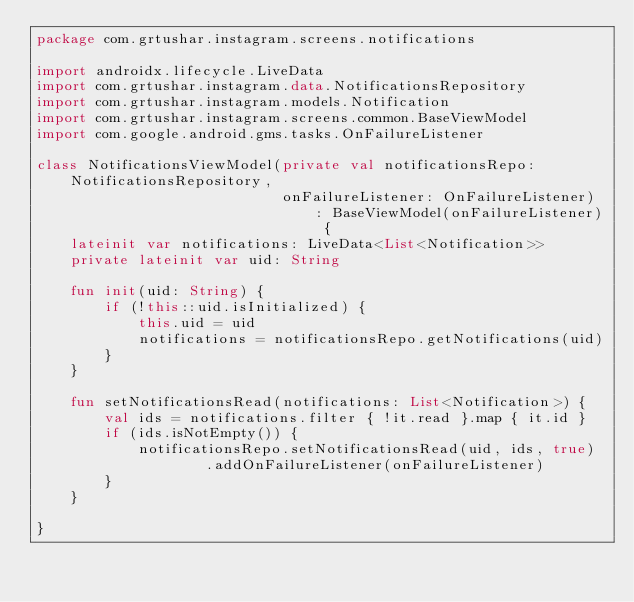Convert code to text. <code><loc_0><loc_0><loc_500><loc_500><_Kotlin_>package com.grtushar.instagram.screens.notifications

import androidx.lifecycle.LiveData
import com.grtushar.instagram.data.NotificationsRepository
import com.grtushar.instagram.models.Notification
import com.grtushar.instagram.screens.common.BaseViewModel
import com.google.android.gms.tasks.OnFailureListener

class NotificationsViewModel(private val notificationsRepo: NotificationsRepository,
                             onFailureListener: OnFailureListener) : BaseViewModel(onFailureListener) {
    lateinit var notifications: LiveData<List<Notification>>
    private lateinit var uid: String

    fun init(uid: String) {
        if (!this::uid.isInitialized) {
            this.uid = uid
            notifications = notificationsRepo.getNotifications(uid)
        }
    }

    fun setNotificationsRead(notifications: List<Notification>) {
        val ids = notifications.filter { !it.read }.map { it.id }
        if (ids.isNotEmpty()) {
            notificationsRepo.setNotificationsRead(uid, ids, true)
                    .addOnFailureListener(onFailureListener)
        }
    }

}</code> 